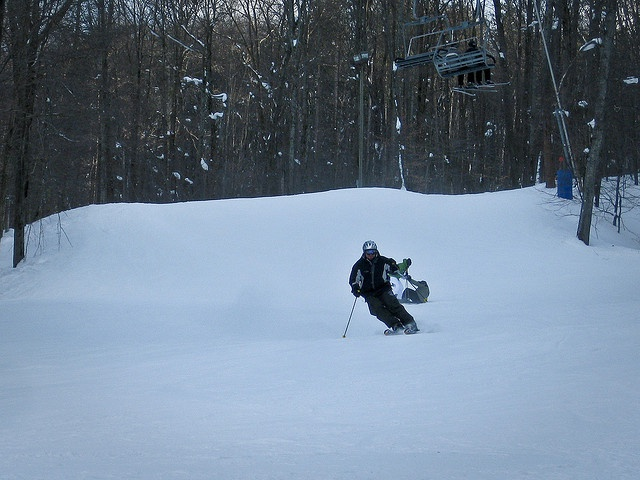Describe the objects in this image and their specific colors. I can see people in black, navy, blue, and gray tones, people in black, blue, and navy tones, and skis in black, gray, and blue tones in this image. 